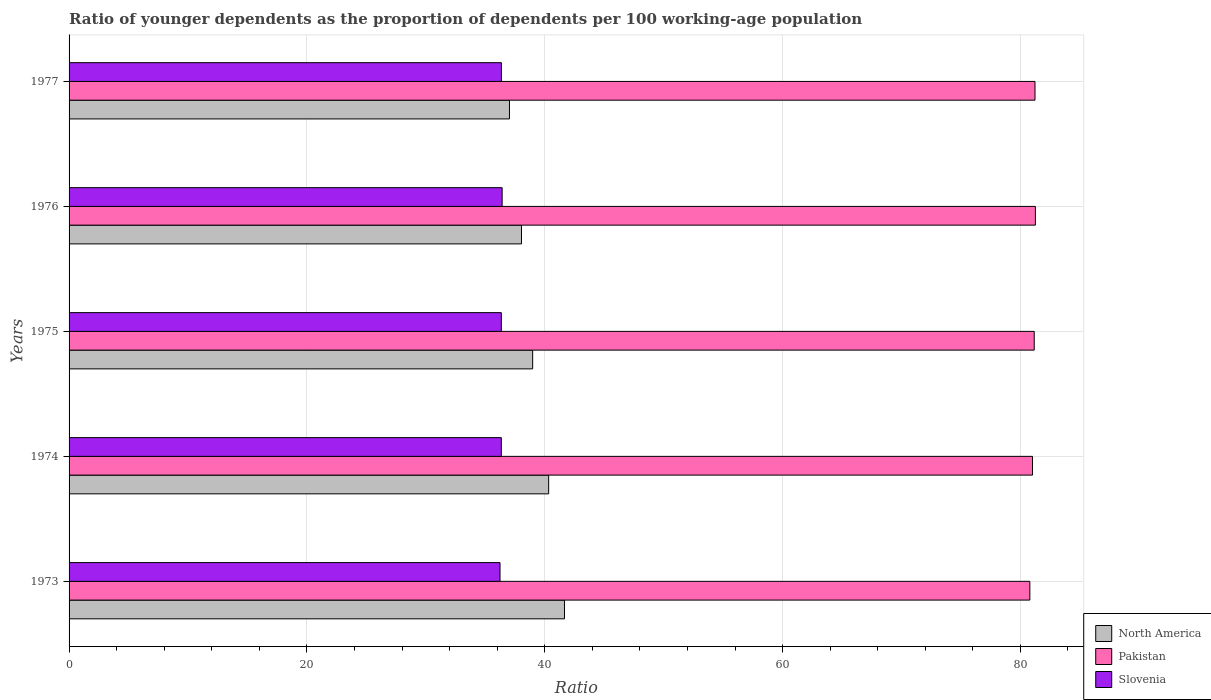Are the number of bars on each tick of the Y-axis equal?
Your response must be concise. Yes. How many bars are there on the 5th tick from the top?
Keep it short and to the point. 3. How many bars are there on the 5th tick from the bottom?
Offer a very short reply. 3. What is the age dependency ratio(young) in North America in 1974?
Provide a succinct answer. 40.33. Across all years, what is the maximum age dependency ratio(young) in Pakistan?
Your response must be concise. 81.26. Across all years, what is the minimum age dependency ratio(young) in Slovenia?
Keep it short and to the point. 36.24. In which year was the age dependency ratio(young) in Pakistan maximum?
Give a very brief answer. 1976. What is the total age dependency ratio(young) in Pakistan in the graph?
Keep it short and to the point. 405.47. What is the difference between the age dependency ratio(young) in Pakistan in 1973 and that in 1976?
Provide a succinct answer. -0.47. What is the difference between the age dependency ratio(young) in Slovenia in 1975 and the age dependency ratio(young) in Pakistan in 1976?
Offer a terse response. -44.91. What is the average age dependency ratio(young) in Pakistan per year?
Your answer should be very brief. 81.09. In the year 1977, what is the difference between the age dependency ratio(young) in Slovenia and age dependency ratio(young) in North America?
Provide a short and direct response. -0.68. In how many years, is the age dependency ratio(young) in Slovenia greater than 4 ?
Your answer should be compact. 5. What is the ratio of the age dependency ratio(young) in Slovenia in 1975 to that in 1977?
Give a very brief answer. 1. What is the difference between the highest and the second highest age dependency ratio(young) in Slovenia?
Provide a short and direct response. 0.06. What is the difference between the highest and the lowest age dependency ratio(young) in Pakistan?
Ensure brevity in your answer.  0.47. What does the 3rd bar from the top in 1973 represents?
Ensure brevity in your answer.  North America. What does the 1st bar from the bottom in 1973 represents?
Your response must be concise. North America. How many years are there in the graph?
Keep it short and to the point. 5. What is the difference between two consecutive major ticks on the X-axis?
Offer a terse response. 20. Does the graph contain any zero values?
Keep it short and to the point. No. Does the graph contain grids?
Your answer should be compact. Yes. What is the title of the graph?
Your response must be concise. Ratio of younger dependents as the proportion of dependents per 100 working-age population. What is the label or title of the X-axis?
Provide a short and direct response. Ratio. What is the Ratio in North America in 1973?
Provide a short and direct response. 41.66. What is the Ratio of Pakistan in 1973?
Give a very brief answer. 80.8. What is the Ratio of Slovenia in 1973?
Provide a succinct answer. 36.24. What is the Ratio in North America in 1974?
Provide a succinct answer. 40.33. What is the Ratio of Pakistan in 1974?
Ensure brevity in your answer.  81.02. What is the Ratio in Slovenia in 1974?
Your answer should be very brief. 36.35. What is the Ratio of North America in 1975?
Your answer should be very brief. 38.99. What is the Ratio in Pakistan in 1975?
Ensure brevity in your answer.  81.16. What is the Ratio of Slovenia in 1975?
Offer a very short reply. 36.35. What is the Ratio in North America in 1976?
Provide a succinct answer. 38.04. What is the Ratio in Pakistan in 1976?
Provide a short and direct response. 81.26. What is the Ratio in Slovenia in 1976?
Provide a short and direct response. 36.42. What is the Ratio of North America in 1977?
Provide a short and direct response. 37.03. What is the Ratio of Pakistan in 1977?
Keep it short and to the point. 81.23. What is the Ratio in Slovenia in 1977?
Your answer should be very brief. 36.36. Across all years, what is the maximum Ratio in North America?
Your answer should be compact. 41.66. Across all years, what is the maximum Ratio of Pakistan?
Provide a short and direct response. 81.26. Across all years, what is the maximum Ratio of Slovenia?
Provide a succinct answer. 36.42. Across all years, what is the minimum Ratio in North America?
Give a very brief answer. 37.03. Across all years, what is the minimum Ratio in Pakistan?
Provide a short and direct response. 80.8. Across all years, what is the minimum Ratio of Slovenia?
Offer a very short reply. 36.24. What is the total Ratio in North America in the graph?
Keep it short and to the point. 196.06. What is the total Ratio of Pakistan in the graph?
Provide a short and direct response. 405.47. What is the total Ratio in Slovenia in the graph?
Your response must be concise. 181.72. What is the difference between the Ratio in North America in 1973 and that in 1974?
Your response must be concise. 1.33. What is the difference between the Ratio of Pakistan in 1973 and that in 1974?
Your answer should be compact. -0.22. What is the difference between the Ratio of Slovenia in 1973 and that in 1974?
Make the answer very short. -0.11. What is the difference between the Ratio in North America in 1973 and that in 1975?
Provide a short and direct response. 2.68. What is the difference between the Ratio of Pakistan in 1973 and that in 1975?
Make the answer very short. -0.37. What is the difference between the Ratio in Slovenia in 1973 and that in 1975?
Keep it short and to the point. -0.11. What is the difference between the Ratio of North America in 1973 and that in 1976?
Offer a terse response. 3.62. What is the difference between the Ratio of Pakistan in 1973 and that in 1976?
Keep it short and to the point. -0.47. What is the difference between the Ratio in Slovenia in 1973 and that in 1976?
Give a very brief answer. -0.18. What is the difference between the Ratio of North America in 1973 and that in 1977?
Your answer should be compact. 4.63. What is the difference between the Ratio in Pakistan in 1973 and that in 1977?
Make the answer very short. -0.43. What is the difference between the Ratio in Slovenia in 1973 and that in 1977?
Your answer should be very brief. -0.12. What is the difference between the Ratio in North America in 1974 and that in 1975?
Provide a succinct answer. 1.35. What is the difference between the Ratio of Pakistan in 1974 and that in 1975?
Give a very brief answer. -0.14. What is the difference between the Ratio in North America in 1974 and that in 1976?
Give a very brief answer. 2.29. What is the difference between the Ratio in Pakistan in 1974 and that in 1976?
Provide a succinct answer. -0.24. What is the difference between the Ratio of Slovenia in 1974 and that in 1976?
Ensure brevity in your answer.  -0.07. What is the difference between the Ratio in North America in 1974 and that in 1977?
Offer a very short reply. 3.3. What is the difference between the Ratio of Pakistan in 1974 and that in 1977?
Your response must be concise. -0.21. What is the difference between the Ratio of Slovenia in 1974 and that in 1977?
Provide a succinct answer. -0.01. What is the difference between the Ratio of North America in 1975 and that in 1976?
Provide a short and direct response. 0.94. What is the difference between the Ratio of Pakistan in 1975 and that in 1976?
Make the answer very short. -0.1. What is the difference between the Ratio in Slovenia in 1975 and that in 1976?
Provide a succinct answer. -0.07. What is the difference between the Ratio of North America in 1975 and that in 1977?
Make the answer very short. 1.95. What is the difference between the Ratio in Pakistan in 1975 and that in 1977?
Ensure brevity in your answer.  -0.06. What is the difference between the Ratio in Slovenia in 1975 and that in 1977?
Ensure brevity in your answer.  -0.01. What is the difference between the Ratio of Pakistan in 1976 and that in 1977?
Provide a short and direct response. 0.03. What is the difference between the Ratio in Slovenia in 1976 and that in 1977?
Provide a succinct answer. 0.06. What is the difference between the Ratio of North America in 1973 and the Ratio of Pakistan in 1974?
Provide a short and direct response. -39.36. What is the difference between the Ratio in North America in 1973 and the Ratio in Slovenia in 1974?
Give a very brief answer. 5.31. What is the difference between the Ratio of Pakistan in 1973 and the Ratio of Slovenia in 1974?
Your answer should be compact. 44.44. What is the difference between the Ratio of North America in 1973 and the Ratio of Pakistan in 1975?
Give a very brief answer. -39.5. What is the difference between the Ratio of North America in 1973 and the Ratio of Slovenia in 1975?
Your response must be concise. 5.31. What is the difference between the Ratio in Pakistan in 1973 and the Ratio in Slovenia in 1975?
Provide a succinct answer. 44.45. What is the difference between the Ratio of North America in 1973 and the Ratio of Pakistan in 1976?
Make the answer very short. -39.6. What is the difference between the Ratio in North America in 1973 and the Ratio in Slovenia in 1976?
Keep it short and to the point. 5.24. What is the difference between the Ratio of Pakistan in 1973 and the Ratio of Slovenia in 1976?
Offer a very short reply. 44.38. What is the difference between the Ratio in North America in 1973 and the Ratio in Pakistan in 1977?
Provide a succinct answer. -39.57. What is the difference between the Ratio of North America in 1973 and the Ratio of Slovenia in 1977?
Your response must be concise. 5.3. What is the difference between the Ratio of Pakistan in 1973 and the Ratio of Slovenia in 1977?
Your answer should be very brief. 44.44. What is the difference between the Ratio in North America in 1974 and the Ratio in Pakistan in 1975?
Your answer should be very brief. -40.83. What is the difference between the Ratio of North America in 1974 and the Ratio of Slovenia in 1975?
Your answer should be compact. 3.98. What is the difference between the Ratio in Pakistan in 1974 and the Ratio in Slovenia in 1975?
Offer a terse response. 44.67. What is the difference between the Ratio of North America in 1974 and the Ratio of Pakistan in 1976?
Provide a short and direct response. -40.93. What is the difference between the Ratio in North America in 1974 and the Ratio in Slovenia in 1976?
Ensure brevity in your answer.  3.91. What is the difference between the Ratio in Pakistan in 1974 and the Ratio in Slovenia in 1976?
Keep it short and to the point. 44.6. What is the difference between the Ratio in North America in 1974 and the Ratio in Pakistan in 1977?
Make the answer very short. -40.9. What is the difference between the Ratio of North America in 1974 and the Ratio of Slovenia in 1977?
Ensure brevity in your answer.  3.97. What is the difference between the Ratio in Pakistan in 1974 and the Ratio in Slovenia in 1977?
Your response must be concise. 44.66. What is the difference between the Ratio in North America in 1975 and the Ratio in Pakistan in 1976?
Make the answer very short. -42.28. What is the difference between the Ratio of North America in 1975 and the Ratio of Slovenia in 1976?
Ensure brevity in your answer.  2.57. What is the difference between the Ratio in Pakistan in 1975 and the Ratio in Slovenia in 1976?
Keep it short and to the point. 44.75. What is the difference between the Ratio in North America in 1975 and the Ratio in Pakistan in 1977?
Offer a very short reply. -42.24. What is the difference between the Ratio of North America in 1975 and the Ratio of Slovenia in 1977?
Offer a very short reply. 2.63. What is the difference between the Ratio in Pakistan in 1975 and the Ratio in Slovenia in 1977?
Give a very brief answer. 44.81. What is the difference between the Ratio in North America in 1976 and the Ratio in Pakistan in 1977?
Provide a succinct answer. -43.18. What is the difference between the Ratio of North America in 1976 and the Ratio of Slovenia in 1977?
Ensure brevity in your answer.  1.69. What is the difference between the Ratio in Pakistan in 1976 and the Ratio in Slovenia in 1977?
Ensure brevity in your answer.  44.9. What is the average Ratio of North America per year?
Ensure brevity in your answer.  39.21. What is the average Ratio in Pakistan per year?
Your answer should be very brief. 81.09. What is the average Ratio of Slovenia per year?
Offer a terse response. 36.34. In the year 1973, what is the difference between the Ratio of North America and Ratio of Pakistan?
Provide a succinct answer. -39.13. In the year 1973, what is the difference between the Ratio of North America and Ratio of Slovenia?
Give a very brief answer. 5.42. In the year 1973, what is the difference between the Ratio of Pakistan and Ratio of Slovenia?
Keep it short and to the point. 44.56. In the year 1974, what is the difference between the Ratio in North America and Ratio in Pakistan?
Make the answer very short. -40.69. In the year 1974, what is the difference between the Ratio in North America and Ratio in Slovenia?
Your answer should be very brief. 3.98. In the year 1974, what is the difference between the Ratio of Pakistan and Ratio of Slovenia?
Offer a very short reply. 44.67. In the year 1975, what is the difference between the Ratio of North America and Ratio of Pakistan?
Offer a terse response. -42.18. In the year 1975, what is the difference between the Ratio of North America and Ratio of Slovenia?
Provide a succinct answer. 2.64. In the year 1975, what is the difference between the Ratio of Pakistan and Ratio of Slovenia?
Provide a short and direct response. 44.81. In the year 1976, what is the difference between the Ratio in North America and Ratio in Pakistan?
Your response must be concise. -43.22. In the year 1976, what is the difference between the Ratio of North America and Ratio of Slovenia?
Offer a very short reply. 1.63. In the year 1976, what is the difference between the Ratio in Pakistan and Ratio in Slovenia?
Offer a terse response. 44.84. In the year 1977, what is the difference between the Ratio in North America and Ratio in Pakistan?
Your response must be concise. -44.19. In the year 1977, what is the difference between the Ratio in North America and Ratio in Slovenia?
Your answer should be very brief. 0.68. In the year 1977, what is the difference between the Ratio of Pakistan and Ratio of Slovenia?
Make the answer very short. 44.87. What is the ratio of the Ratio of North America in 1973 to that in 1974?
Your answer should be compact. 1.03. What is the ratio of the Ratio in Pakistan in 1973 to that in 1974?
Your answer should be compact. 1. What is the ratio of the Ratio of Slovenia in 1973 to that in 1974?
Make the answer very short. 1. What is the ratio of the Ratio in North America in 1973 to that in 1975?
Your answer should be compact. 1.07. What is the ratio of the Ratio in Pakistan in 1973 to that in 1975?
Provide a succinct answer. 1. What is the ratio of the Ratio of Slovenia in 1973 to that in 1975?
Offer a very short reply. 1. What is the ratio of the Ratio in North America in 1973 to that in 1976?
Your answer should be very brief. 1.1. What is the ratio of the Ratio in Slovenia in 1973 to that in 1976?
Your answer should be compact. 1. What is the ratio of the Ratio in North America in 1973 to that in 1977?
Your response must be concise. 1.12. What is the ratio of the Ratio in Pakistan in 1973 to that in 1977?
Your response must be concise. 0.99. What is the ratio of the Ratio in Slovenia in 1973 to that in 1977?
Give a very brief answer. 1. What is the ratio of the Ratio of North America in 1974 to that in 1975?
Offer a terse response. 1.03. What is the ratio of the Ratio of Pakistan in 1974 to that in 1975?
Offer a terse response. 1. What is the ratio of the Ratio of Slovenia in 1974 to that in 1975?
Ensure brevity in your answer.  1. What is the ratio of the Ratio of North America in 1974 to that in 1976?
Your response must be concise. 1.06. What is the ratio of the Ratio in Slovenia in 1974 to that in 1976?
Offer a terse response. 1. What is the ratio of the Ratio in North America in 1974 to that in 1977?
Keep it short and to the point. 1.09. What is the ratio of the Ratio in North America in 1975 to that in 1976?
Offer a terse response. 1.02. What is the ratio of the Ratio in Pakistan in 1975 to that in 1976?
Provide a succinct answer. 1. What is the ratio of the Ratio of North America in 1975 to that in 1977?
Make the answer very short. 1.05. What is the ratio of the Ratio of Pakistan in 1975 to that in 1977?
Give a very brief answer. 1. What is the ratio of the Ratio of North America in 1976 to that in 1977?
Your response must be concise. 1.03. What is the ratio of the Ratio of Pakistan in 1976 to that in 1977?
Provide a short and direct response. 1. What is the difference between the highest and the second highest Ratio of North America?
Provide a short and direct response. 1.33. What is the difference between the highest and the second highest Ratio of Pakistan?
Offer a very short reply. 0.03. What is the difference between the highest and the second highest Ratio of Slovenia?
Provide a short and direct response. 0.06. What is the difference between the highest and the lowest Ratio in North America?
Offer a terse response. 4.63. What is the difference between the highest and the lowest Ratio of Pakistan?
Make the answer very short. 0.47. What is the difference between the highest and the lowest Ratio in Slovenia?
Give a very brief answer. 0.18. 